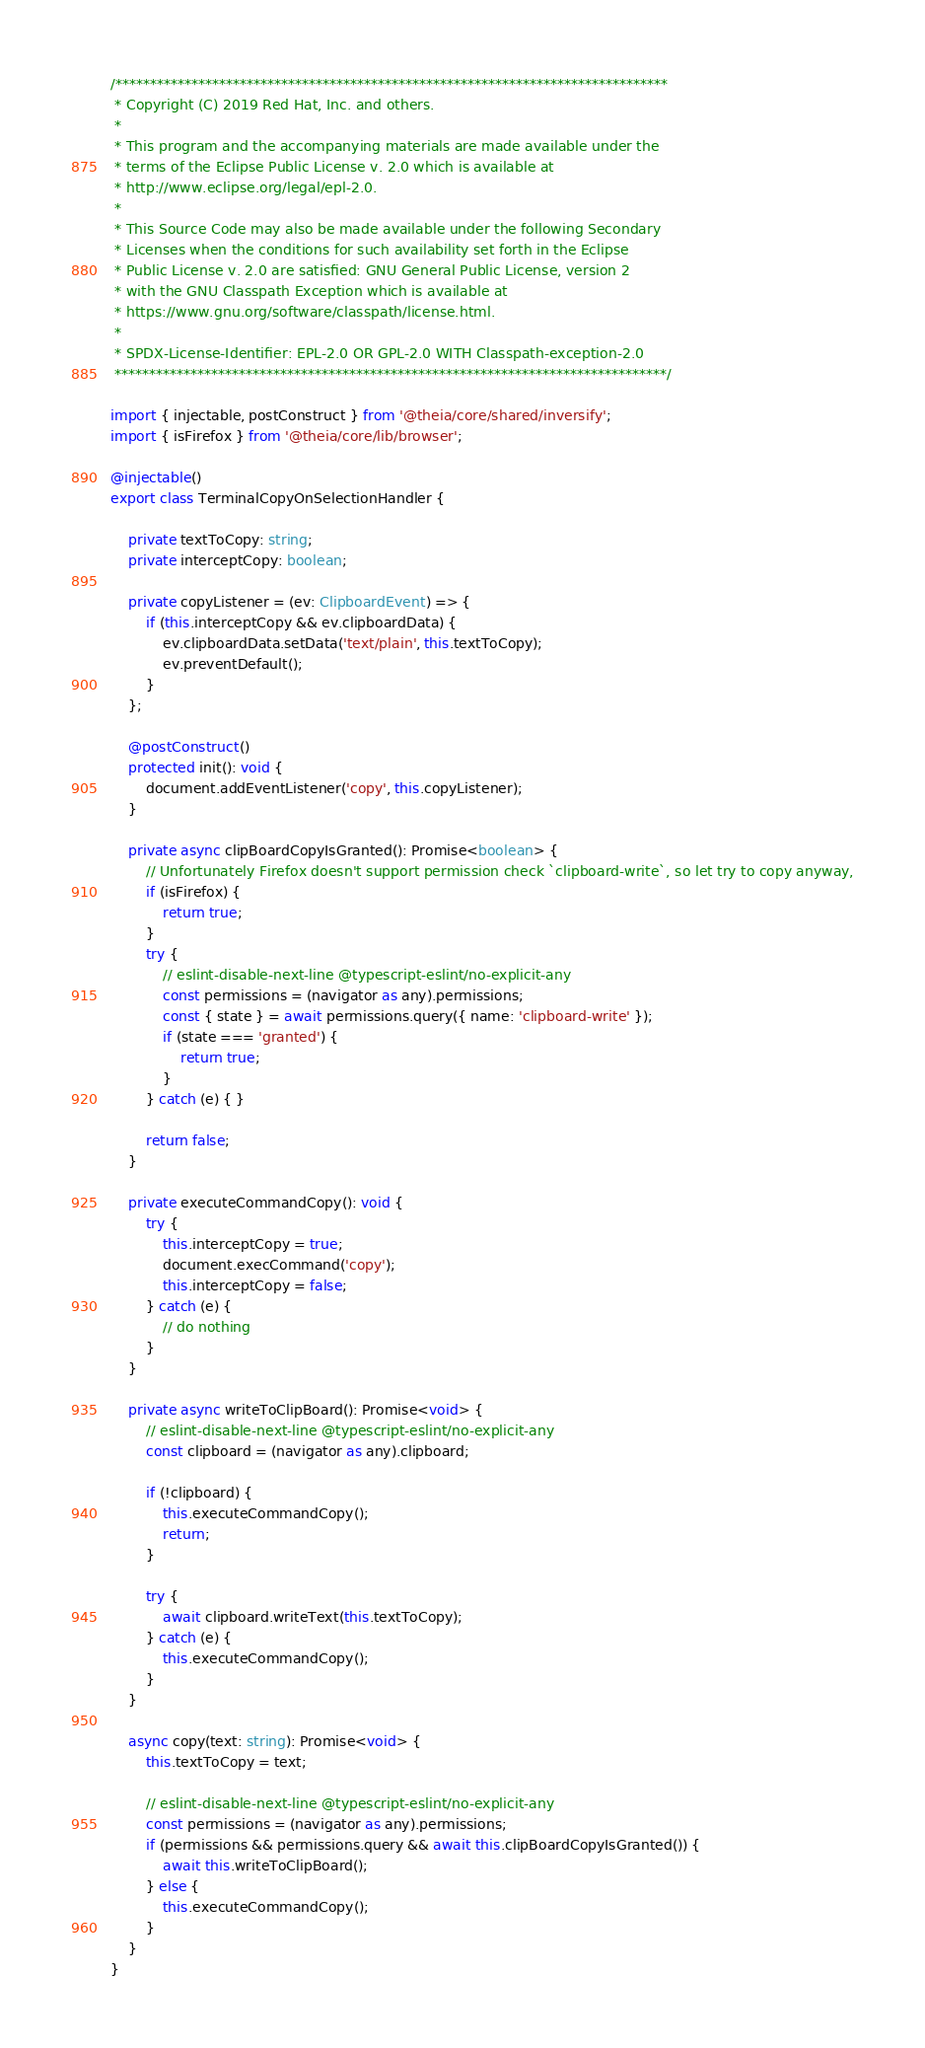<code> <loc_0><loc_0><loc_500><loc_500><_TypeScript_>/********************************************************************************
 * Copyright (C) 2019 Red Hat, Inc. and others.
 *
 * This program and the accompanying materials are made available under the
 * terms of the Eclipse Public License v. 2.0 which is available at
 * http://www.eclipse.org/legal/epl-2.0.
 *
 * This Source Code may also be made available under the following Secondary
 * Licenses when the conditions for such availability set forth in the Eclipse
 * Public License v. 2.0 are satisfied: GNU General Public License, version 2
 * with the GNU Classpath Exception which is available at
 * https://www.gnu.org/software/classpath/license.html.
 *
 * SPDX-License-Identifier: EPL-2.0 OR GPL-2.0 WITH Classpath-exception-2.0
 ********************************************************************************/

import { injectable, postConstruct } from '@theia/core/shared/inversify';
import { isFirefox } from '@theia/core/lib/browser';

@injectable()
export class TerminalCopyOnSelectionHandler {

    private textToCopy: string;
    private interceptCopy: boolean;

    private copyListener = (ev: ClipboardEvent) => {
        if (this.interceptCopy && ev.clipboardData) {
            ev.clipboardData.setData('text/plain', this.textToCopy);
            ev.preventDefault();
        }
    };

    @postConstruct()
    protected init(): void {
        document.addEventListener('copy', this.copyListener);
    }

    private async clipBoardCopyIsGranted(): Promise<boolean> {
        // Unfortunately Firefox doesn't support permission check `clipboard-write`, so let try to copy anyway,
        if (isFirefox) {
            return true;
        }
        try {
            // eslint-disable-next-line @typescript-eslint/no-explicit-any
            const permissions = (navigator as any).permissions;
            const { state } = await permissions.query({ name: 'clipboard-write' });
            if (state === 'granted') {
                return true;
            }
        } catch (e) { }

        return false;
    }

    private executeCommandCopy(): void {
        try {
            this.interceptCopy = true;
            document.execCommand('copy');
            this.interceptCopy = false;
        } catch (e) {
            // do nothing
        }
    }

    private async writeToClipBoard(): Promise<void> {
        // eslint-disable-next-line @typescript-eslint/no-explicit-any
        const clipboard = (navigator as any).clipboard;

        if (!clipboard) {
            this.executeCommandCopy();
            return;
        }

        try {
            await clipboard.writeText(this.textToCopy);
        } catch (e) {
            this.executeCommandCopy();
        }
    }

    async copy(text: string): Promise<void> {
        this.textToCopy = text;

        // eslint-disable-next-line @typescript-eslint/no-explicit-any
        const permissions = (navigator as any).permissions;
        if (permissions && permissions.query && await this.clipBoardCopyIsGranted()) {
            await this.writeToClipBoard();
        } else {
            this.executeCommandCopy();
        }
    }
}
</code> 